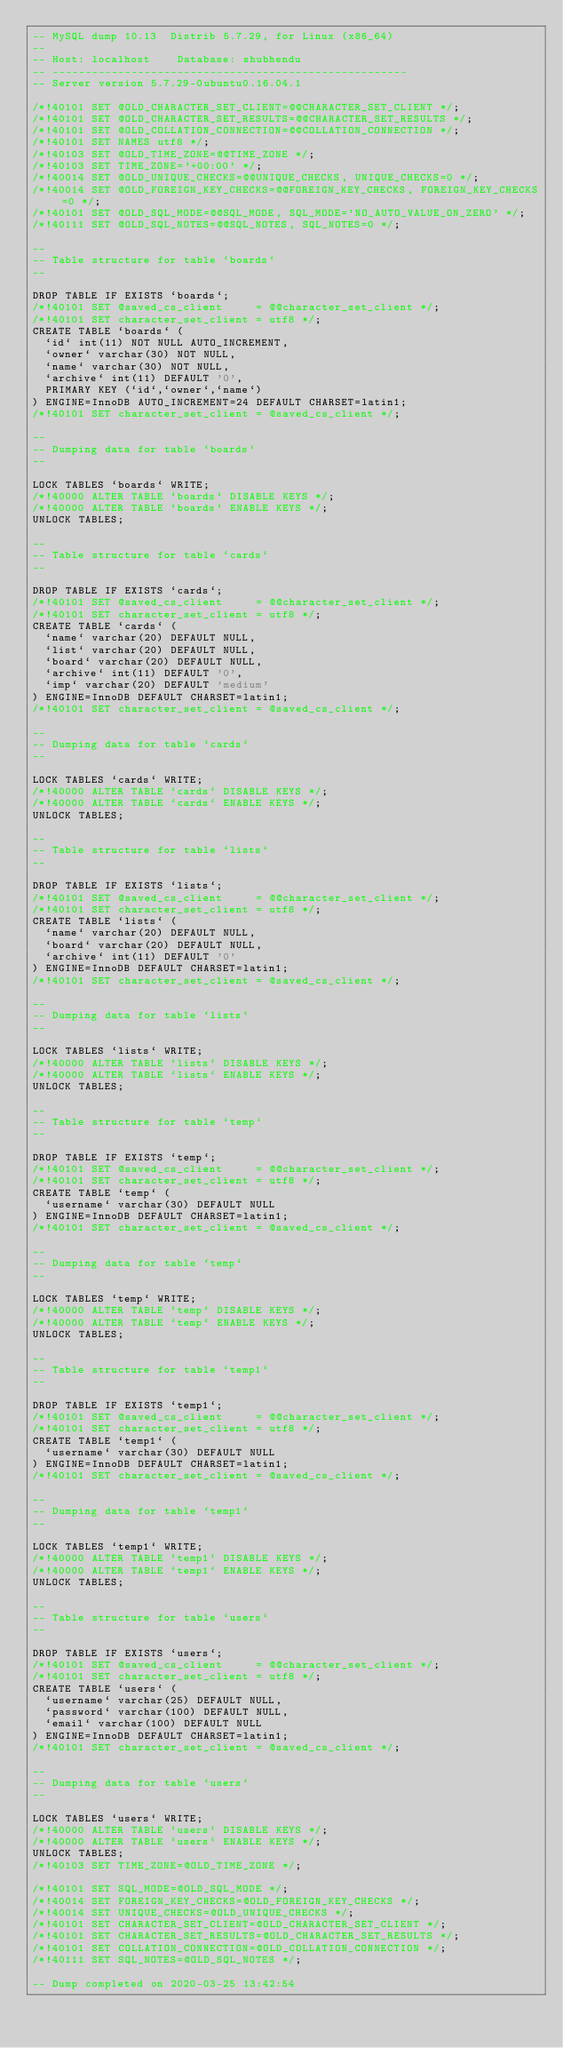<code> <loc_0><loc_0><loc_500><loc_500><_SQL_>-- MySQL dump 10.13  Distrib 5.7.29, for Linux (x86_64)
--
-- Host: localhost    Database: shubhendu
-- ------------------------------------------------------
-- Server version	5.7.29-0ubuntu0.16.04.1

/*!40101 SET @OLD_CHARACTER_SET_CLIENT=@@CHARACTER_SET_CLIENT */;
/*!40101 SET @OLD_CHARACTER_SET_RESULTS=@@CHARACTER_SET_RESULTS */;
/*!40101 SET @OLD_COLLATION_CONNECTION=@@COLLATION_CONNECTION */;
/*!40101 SET NAMES utf8 */;
/*!40103 SET @OLD_TIME_ZONE=@@TIME_ZONE */;
/*!40103 SET TIME_ZONE='+00:00' */;
/*!40014 SET @OLD_UNIQUE_CHECKS=@@UNIQUE_CHECKS, UNIQUE_CHECKS=0 */;
/*!40014 SET @OLD_FOREIGN_KEY_CHECKS=@@FOREIGN_KEY_CHECKS, FOREIGN_KEY_CHECKS=0 */;
/*!40101 SET @OLD_SQL_MODE=@@SQL_MODE, SQL_MODE='NO_AUTO_VALUE_ON_ZERO' */;
/*!40111 SET @OLD_SQL_NOTES=@@SQL_NOTES, SQL_NOTES=0 */;

--
-- Table structure for table `boards`
--

DROP TABLE IF EXISTS `boards`;
/*!40101 SET @saved_cs_client     = @@character_set_client */;
/*!40101 SET character_set_client = utf8 */;
CREATE TABLE `boards` (
  `id` int(11) NOT NULL AUTO_INCREMENT,
  `owner` varchar(30) NOT NULL,
  `name` varchar(30) NOT NULL,
  `archive` int(11) DEFAULT '0',
  PRIMARY KEY (`id`,`owner`,`name`)
) ENGINE=InnoDB AUTO_INCREMENT=24 DEFAULT CHARSET=latin1;
/*!40101 SET character_set_client = @saved_cs_client */;

--
-- Dumping data for table `boards`
--

LOCK TABLES `boards` WRITE;
/*!40000 ALTER TABLE `boards` DISABLE KEYS */;
/*!40000 ALTER TABLE `boards` ENABLE KEYS */;
UNLOCK TABLES;

--
-- Table structure for table `cards`
--

DROP TABLE IF EXISTS `cards`;
/*!40101 SET @saved_cs_client     = @@character_set_client */;
/*!40101 SET character_set_client = utf8 */;
CREATE TABLE `cards` (
  `name` varchar(20) DEFAULT NULL,
  `list` varchar(20) DEFAULT NULL,
  `board` varchar(20) DEFAULT NULL,
  `archive` int(11) DEFAULT '0',
  `imp` varchar(20) DEFAULT 'medium'
) ENGINE=InnoDB DEFAULT CHARSET=latin1;
/*!40101 SET character_set_client = @saved_cs_client */;

--
-- Dumping data for table `cards`
--

LOCK TABLES `cards` WRITE;
/*!40000 ALTER TABLE `cards` DISABLE KEYS */;
/*!40000 ALTER TABLE `cards` ENABLE KEYS */;
UNLOCK TABLES;

--
-- Table structure for table `lists`
--

DROP TABLE IF EXISTS `lists`;
/*!40101 SET @saved_cs_client     = @@character_set_client */;
/*!40101 SET character_set_client = utf8 */;
CREATE TABLE `lists` (
  `name` varchar(20) DEFAULT NULL,
  `board` varchar(20) DEFAULT NULL,
  `archive` int(11) DEFAULT '0'
) ENGINE=InnoDB DEFAULT CHARSET=latin1;
/*!40101 SET character_set_client = @saved_cs_client */;

--
-- Dumping data for table `lists`
--

LOCK TABLES `lists` WRITE;
/*!40000 ALTER TABLE `lists` DISABLE KEYS */;
/*!40000 ALTER TABLE `lists` ENABLE KEYS */;
UNLOCK TABLES;

--
-- Table structure for table `temp`
--

DROP TABLE IF EXISTS `temp`;
/*!40101 SET @saved_cs_client     = @@character_set_client */;
/*!40101 SET character_set_client = utf8 */;
CREATE TABLE `temp` (
  `username` varchar(30) DEFAULT NULL
) ENGINE=InnoDB DEFAULT CHARSET=latin1;
/*!40101 SET character_set_client = @saved_cs_client */;

--
-- Dumping data for table `temp`
--

LOCK TABLES `temp` WRITE;
/*!40000 ALTER TABLE `temp` DISABLE KEYS */;
/*!40000 ALTER TABLE `temp` ENABLE KEYS */;
UNLOCK TABLES;

--
-- Table structure for table `temp1`
--

DROP TABLE IF EXISTS `temp1`;
/*!40101 SET @saved_cs_client     = @@character_set_client */;
/*!40101 SET character_set_client = utf8 */;
CREATE TABLE `temp1` (
  `username` varchar(30) DEFAULT NULL
) ENGINE=InnoDB DEFAULT CHARSET=latin1;
/*!40101 SET character_set_client = @saved_cs_client */;

--
-- Dumping data for table `temp1`
--

LOCK TABLES `temp1` WRITE;
/*!40000 ALTER TABLE `temp1` DISABLE KEYS */;
/*!40000 ALTER TABLE `temp1` ENABLE KEYS */;
UNLOCK TABLES;

--
-- Table structure for table `users`
--

DROP TABLE IF EXISTS `users`;
/*!40101 SET @saved_cs_client     = @@character_set_client */;
/*!40101 SET character_set_client = utf8 */;
CREATE TABLE `users` (
  `username` varchar(25) DEFAULT NULL,
  `password` varchar(100) DEFAULT NULL,
  `email` varchar(100) DEFAULT NULL
) ENGINE=InnoDB DEFAULT CHARSET=latin1;
/*!40101 SET character_set_client = @saved_cs_client */;

--
-- Dumping data for table `users`
--

LOCK TABLES `users` WRITE;
/*!40000 ALTER TABLE `users` DISABLE KEYS */;
/*!40000 ALTER TABLE `users` ENABLE KEYS */;
UNLOCK TABLES;
/*!40103 SET TIME_ZONE=@OLD_TIME_ZONE */;

/*!40101 SET SQL_MODE=@OLD_SQL_MODE */;
/*!40014 SET FOREIGN_KEY_CHECKS=@OLD_FOREIGN_KEY_CHECKS */;
/*!40014 SET UNIQUE_CHECKS=@OLD_UNIQUE_CHECKS */;
/*!40101 SET CHARACTER_SET_CLIENT=@OLD_CHARACTER_SET_CLIENT */;
/*!40101 SET CHARACTER_SET_RESULTS=@OLD_CHARACTER_SET_RESULTS */;
/*!40101 SET COLLATION_CONNECTION=@OLD_COLLATION_CONNECTION */;
/*!40111 SET SQL_NOTES=@OLD_SQL_NOTES */;

-- Dump completed on 2020-03-25 13:42:54
</code> 